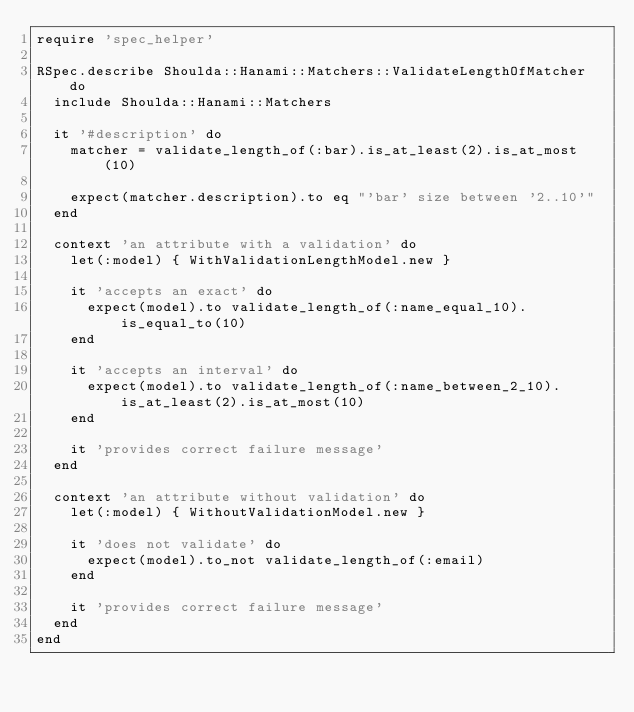Convert code to text. <code><loc_0><loc_0><loc_500><loc_500><_Ruby_>require 'spec_helper'

RSpec.describe Shoulda::Hanami::Matchers::ValidateLengthOfMatcher do
  include Shoulda::Hanami::Matchers

  it '#description' do
    matcher = validate_length_of(:bar).is_at_least(2).is_at_most(10)

    expect(matcher.description).to eq "'bar' size between '2..10'"
  end

  context 'an attribute with a validation' do
    let(:model) { WithValidationLengthModel.new }

    it 'accepts an exact' do
      expect(model).to validate_length_of(:name_equal_10).is_equal_to(10)
    end

    it 'accepts an interval' do
      expect(model).to validate_length_of(:name_between_2_10).is_at_least(2).is_at_most(10)
    end

    it 'provides correct failure message'
  end

  context 'an attribute without validation' do
    let(:model) { WithoutValidationModel.new }

    it 'does not validate' do
      expect(model).to_not validate_length_of(:email)
    end

    it 'provides correct failure message'
  end
end
</code> 